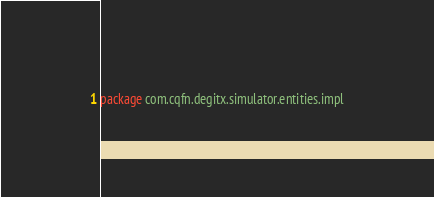Convert code to text. <code><loc_0><loc_0><loc_500><loc_500><_Kotlin_>package com.cqfn.degitx.simulator.entities.impl
</code> 